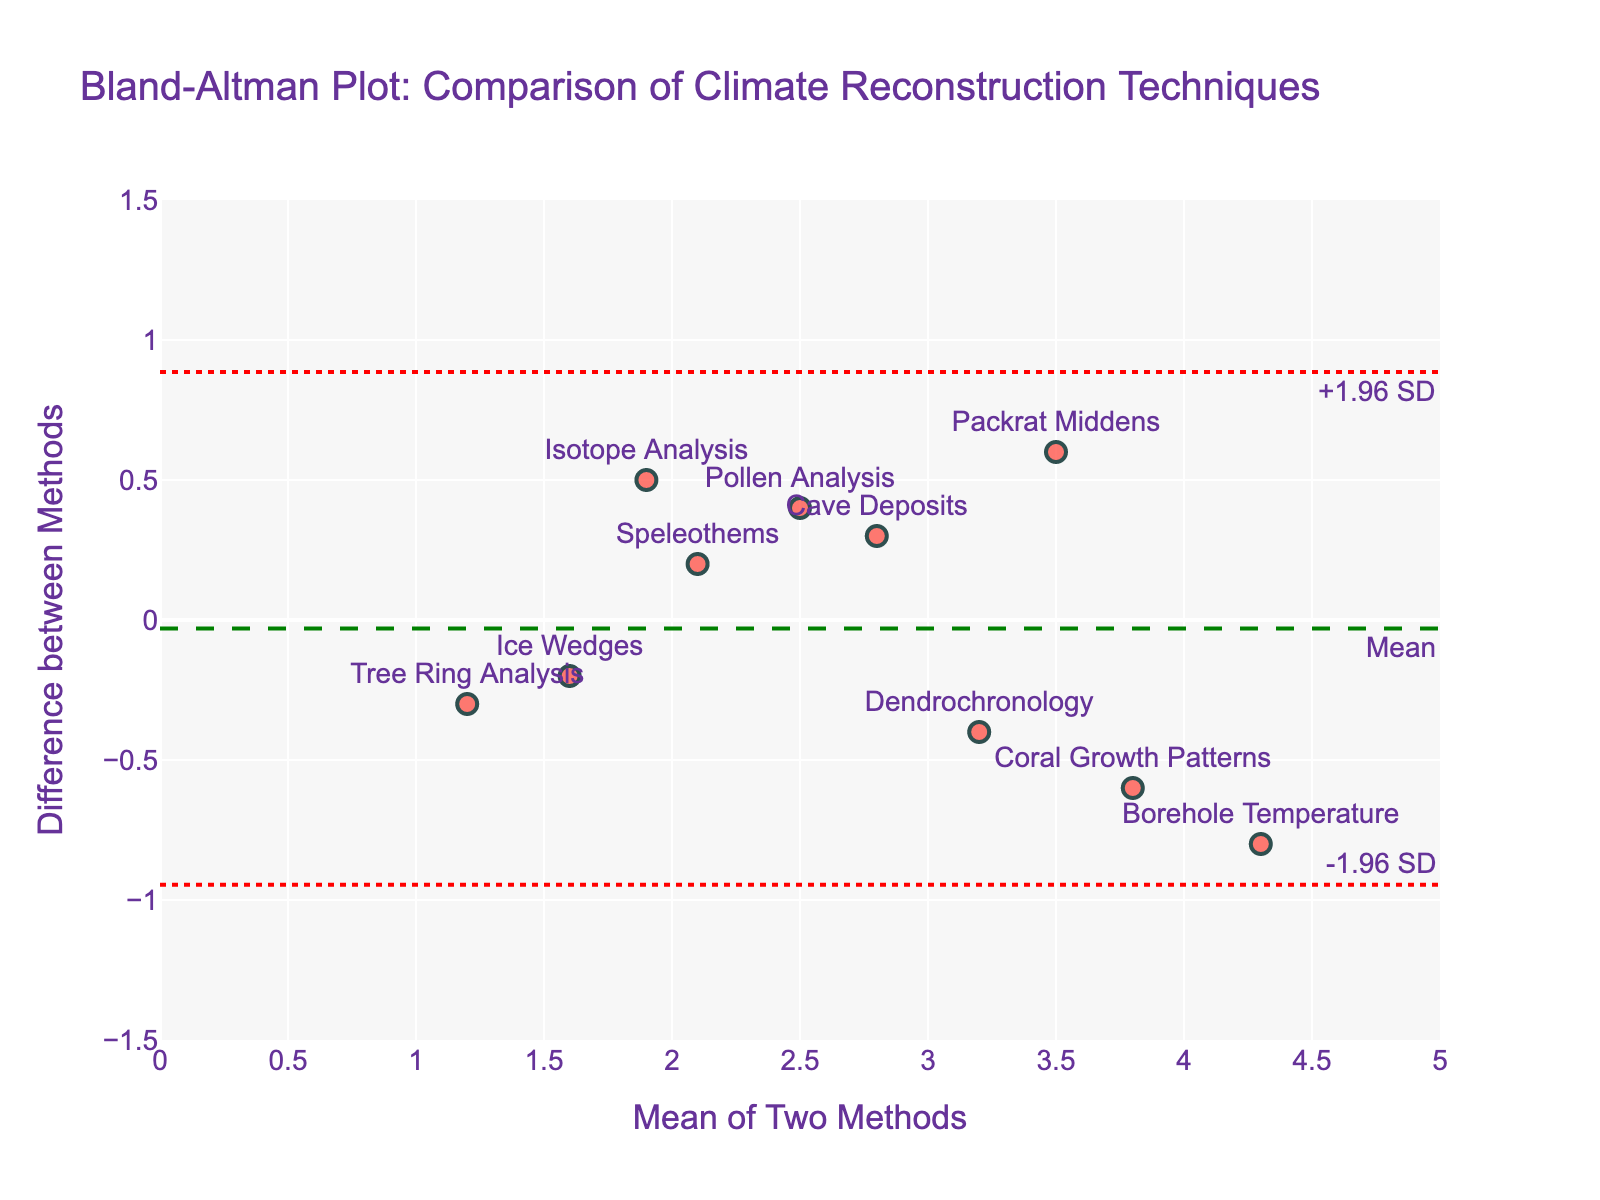What's the title of the plot? The title is displayed at the very top of the plot. It provides a summary of what the plot represents.
Answer: Bland-Altman Plot: Comparison of Climate Reconstruction Techniques What's the difference between Tree Ring Analysis and Ice Core Analysis? Locate Tree Ring Analysis on the plot. The y-axis value for Tree Ring Analysis indicates the difference.
Answer: -0.3 Which method pair shows the smallest difference? Identify the point on the y-axis closest to zero, and find the corresponding method pair.
Answer: Ice Wedges and Tree Stumps What are the upper and lower limits of agreement in the plot? The limits of agreement are generally calculated as mean difference ± 1.96 standard deviations. These are visually represented by the dashed red lines on the plot. Locate their values on the y-axis.
Answer: +1.96 SD and -1.96 SD Which method has the highest mean value and what is the corresponding difference? Locate the highest x-axis value and find the corresponding y-axis value and text label.
Answer: Borehole Temperature and Marine Sediments; -0.8 How many methods show a positive difference? Count the number of data points located above the zero line on the y-axis.
Answer: 4 Which method pair has a mean value close to 3.0 and what is its difference? Locate data points around x = 3.0 on the x-axis and find the corresponding y-values and method pair labels.
Answer: Dendrochronology and Fossil Leaves; -0.4 Out of Pollen Analysis and Historical Records versus Coral Growth Patterns and Lake Sediments, which pair has a larger difference? Compare the y-axis values of both pairs and identify which one is larger.
Answer: Coral Growth Patterns and Lake Sediments Do any methods have differences above +0.5 or below -0.5? If so, which ones? Look for data points that are above +0.5 or below -0.5 on the y-axis and note their labels.
Answer: Pollen Analysis and Historical Records; Isotope Analysis and Ancient Documents; Borehole Temperature and Marine Sediments; Coral Growth Patterns and Lake Sediments Which method pair shows the closest to the average difference, and what is this value? Visually identify the data points nearest to the dashed green mean line on the y-axis and find the corresponding method pair labels and y-values.
Answer: Speleothems and Glacial Deposits; 0.2 